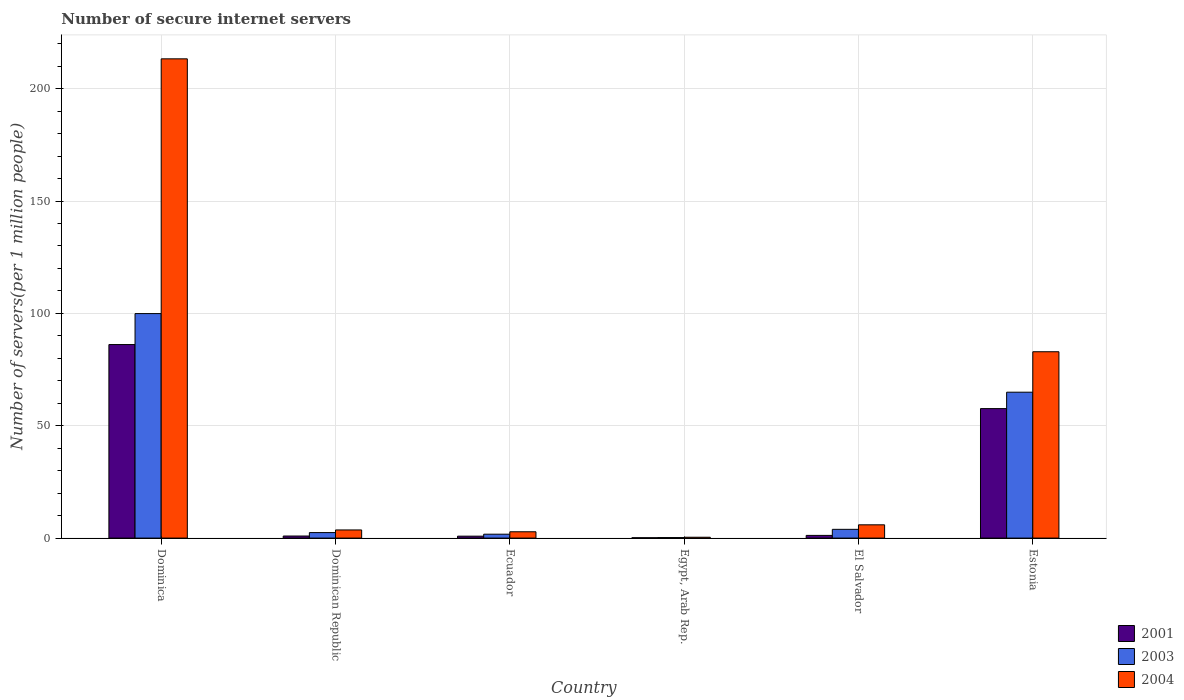How many different coloured bars are there?
Offer a terse response. 3. How many groups of bars are there?
Offer a terse response. 6. Are the number of bars per tick equal to the number of legend labels?
Provide a succinct answer. Yes. What is the label of the 5th group of bars from the left?
Make the answer very short. El Salvador. In how many cases, is the number of bars for a given country not equal to the number of legend labels?
Your response must be concise. 0. What is the number of secure internet servers in 2001 in Egypt, Arab Rep.?
Give a very brief answer. 0.16. Across all countries, what is the maximum number of secure internet servers in 2004?
Ensure brevity in your answer.  213.3. Across all countries, what is the minimum number of secure internet servers in 2004?
Offer a very short reply. 0.38. In which country was the number of secure internet servers in 2003 maximum?
Your answer should be very brief. Dominica. In which country was the number of secure internet servers in 2001 minimum?
Ensure brevity in your answer.  Egypt, Arab Rep. What is the total number of secure internet servers in 2001 in the graph?
Make the answer very short. 146.9. What is the difference between the number of secure internet servers in 2001 in Dominica and that in Egypt, Arab Rep.?
Make the answer very short. 85.97. What is the difference between the number of secure internet servers in 2004 in Estonia and the number of secure internet servers in 2003 in Dominica?
Offer a terse response. -16.98. What is the average number of secure internet servers in 2003 per country?
Your answer should be very brief. 28.86. What is the difference between the number of secure internet servers of/in 2003 and number of secure internet servers of/in 2001 in Estonia?
Give a very brief answer. 7.3. In how many countries, is the number of secure internet servers in 2004 greater than 130?
Make the answer very short. 1. What is the ratio of the number of secure internet servers in 2001 in El Salvador to that in Estonia?
Your answer should be very brief. 0.02. Is the number of secure internet servers in 2004 in El Salvador less than that in Estonia?
Provide a short and direct response. Yes. Is the difference between the number of secure internet servers in 2003 in Egypt, Arab Rep. and Estonia greater than the difference between the number of secure internet servers in 2001 in Egypt, Arab Rep. and Estonia?
Give a very brief answer. No. What is the difference between the highest and the second highest number of secure internet servers in 2003?
Offer a terse response. -34.99. What is the difference between the highest and the lowest number of secure internet servers in 2003?
Your response must be concise. 99.68. In how many countries, is the number of secure internet servers in 2003 greater than the average number of secure internet servers in 2003 taken over all countries?
Provide a succinct answer. 2. What does the 3rd bar from the right in Estonia represents?
Your answer should be compact. 2001. How many bars are there?
Provide a succinct answer. 18. Does the graph contain any zero values?
Ensure brevity in your answer.  No. Does the graph contain grids?
Make the answer very short. Yes. Where does the legend appear in the graph?
Ensure brevity in your answer.  Bottom right. How are the legend labels stacked?
Your answer should be compact. Vertical. What is the title of the graph?
Your answer should be very brief. Number of secure internet servers. Does "1970" appear as one of the legend labels in the graph?
Keep it short and to the point. No. What is the label or title of the X-axis?
Give a very brief answer. Country. What is the label or title of the Y-axis?
Give a very brief answer. Number of servers(per 1 million people). What is the Number of servers(per 1 million people) in 2001 in Dominica?
Your answer should be compact. 86.13. What is the Number of servers(per 1 million people) of 2003 in Dominica?
Provide a short and direct response. 99.92. What is the Number of servers(per 1 million people) of 2004 in Dominica?
Offer a very short reply. 213.3. What is the Number of servers(per 1 million people) in 2001 in Dominican Republic?
Offer a terse response. 0.92. What is the Number of servers(per 1 million people) in 2003 in Dominican Republic?
Ensure brevity in your answer.  2.45. What is the Number of servers(per 1 million people) of 2004 in Dominican Republic?
Provide a succinct answer. 3.63. What is the Number of servers(per 1 million people) of 2001 in Ecuador?
Ensure brevity in your answer.  0.86. What is the Number of servers(per 1 million people) in 2003 in Ecuador?
Your answer should be very brief. 1.73. What is the Number of servers(per 1 million people) in 2004 in Ecuador?
Your answer should be very brief. 2.81. What is the Number of servers(per 1 million people) of 2001 in Egypt, Arab Rep.?
Provide a succinct answer. 0.16. What is the Number of servers(per 1 million people) of 2003 in Egypt, Arab Rep.?
Your response must be concise. 0.24. What is the Number of servers(per 1 million people) in 2004 in Egypt, Arab Rep.?
Offer a very short reply. 0.38. What is the Number of servers(per 1 million people) in 2001 in El Salvador?
Your answer should be very brief. 1.2. What is the Number of servers(per 1 million people) in 2003 in El Salvador?
Provide a short and direct response. 3.9. What is the Number of servers(per 1 million people) in 2004 in El Salvador?
Your answer should be compact. 5.91. What is the Number of servers(per 1 million people) in 2001 in Estonia?
Your answer should be compact. 57.63. What is the Number of servers(per 1 million people) in 2003 in Estonia?
Ensure brevity in your answer.  64.93. What is the Number of servers(per 1 million people) in 2004 in Estonia?
Keep it short and to the point. 82.93. Across all countries, what is the maximum Number of servers(per 1 million people) in 2001?
Provide a short and direct response. 86.13. Across all countries, what is the maximum Number of servers(per 1 million people) of 2003?
Your answer should be compact. 99.92. Across all countries, what is the maximum Number of servers(per 1 million people) of 2004?
Keep it short and to the point. 213.3. Across all countries, what is the minimum Number of servers(per 1 million people) in 2001?
Your answer should be compact. 0.16. Across all countries, what is the minimum Number of servers(per 1 million people) of 2003?
Your response must be concise. 0.24. Across all countries, what is the minimum Number of servers(per 1 million people) of 2004?
Keep it short and to the point. 0.38. What is the total Number of servers(per 1 million people) in 2001 in the graph?
Offer a very short reply. 146.9. What is the total Number of servers(per 1 million people) of 2003 in the graph?
Your response must be concise. 173.16. What is the total Number of servers(per 1 million people) of 2004 in the graph?
Provide a short and direct response. 308.95. What is the difference between the Number of servers(per 1 million people) of 2001 in Dominica and that in Dominican Republic?
Your answer should be compact. 85.21. What is the difference between the Number of servers(per 1 million people) in 2003 in Dominica and that in Dominican Republic?
Offer a very short reply. 97.46. What is the difference between the Number of servers(per 1 million people) of 2004 in Dominica and that in Dominican Republic?
Make the answer very short. 209.67. What is the difference between the Number of servers(per 1 million people) in 2001 in Dominica and that in Ecuador?
Ensure brevity in your answer.  85.28. What is the difference between the Number of servers(per 1 million people) of 2003 in Dominica and that in Ecuador?
Ensure brevity in your answer.  98.19. What is the difference between the Number of servers(per 1 million people) in 2004 in Dominica and that in Ecuador?
Provide a short and direct response. 210.48. What is the difference between the Number of servers(per 1 million people) of 2001 in Dominica and that in Egypt, Arab Rep.?
Your response must be concise. 85.97. What is the difference between the Number of servers(per 1 million people) in 2003 in Dominica and that in Egypt, Arab Rep.?
Offer a very short reply. 99.68. What is the difference between the Number of servers(per 1 million people) of 2004 in Dominica and that in Egypt, Arab Rep.?
Give a very brief answer. 212.91. What is the difference between the Number of servers(per 1 million people) of 2001 in Dominica and that in El Salvador?
Keep it short and to the point. 84.94. What is the difference between the Number of servers(per 1 million people) of 2003 in Dominica and that in El Salvador?
Offer a very short reply. 96.02. What is the difference between the Number of servers(per 1 million people) in 2004 in Dominica and that in El Salvador?
Offer a terse response. 207.39. What is the difference between the Number of servers(per 1 million people) in 2001 in Dominica and that in Estonia?
Keep it short and to the point. 28.5. What is the difference between the Number of servers(per 1 million people) of 2003 in Dominica and that in Estonia?
Offer a terse response. 34.99. What is the difference between the Number of servers(per 1 million people) in 2004 in Dominica and that in Estonia?
Your answer should be very brief. 130.36. What is the difference between the Number of servers(per 1 million people) of 2001 in Dominican Republic and that in Ecuador?
Provide a short and direct response. 0.06. What is the difference between the Number of servers(per 1 million people) in 2003 in Dominican Republic and that in Ecuador?
Your answer should be compact. 0.72. What is the difference between the Number of servers(per 1 million people) in 2004 in Dominican Republic and that in Ecuador?
Your response must be concise. 0.81. What is the difference between the Number of servers(per 1 million people) of 2001 in Dominican Republic and that in Egypt, Arab Rep.?
Offer a very short reply. 0.76. What is the difference between the Number of servers(per 1 million people) in 2003 in Dominican Republic and that in Egypt, Arab Rep.?
Your response must be concise. 2.22. What is the difference between the Number of servers(per 1 million people) of 2004 in Dominican Republic and that in Egypt, Arab Rep.?
Provide a short and direct response. 3.24. What is the difference between the Number of servers(per 1 million people) of 2001 in Dominican Republic and that in El Salvador?
Provide a short and direct response. -0.28. What is the difference between the Number of servers(per 1 million people) in 2003 in Dominican Republic and that in El Salvador?
Make the answer very short. -1.44. What is the difference between the Number of servers(per 1 million people) of 2004 in Dominican Republic and that in El Salvador?
Give a very brief answer. -2.28. What is the difference between the Number of servers(per 1 million people) in 2001 in Dominican Republic and that in Estonia?
Ensure brevity in your answer.  -56.71. What is the difference between the Number of servers(per 1 million people) of 2003 in Dominican Republic and that in Estonia?
Keep it short and to the point. -62.48. What is the difference between the Number of servers(per 1 million people) in 2004 in Dominican Republic and that in Estonia?
Provide a succinct answer. -79.31. What is the difference between the Number of servers(per 1 million people) in 2001 in Ecuador and that in Egypt, Arab Rep.?
Make the answer very short. 0.7. What is the difference between the Number of servers(per 1 million people) in 2003 in Ecuador and that in Egypt, Arab Rep.?
Provide a short and direct response. 1.5. What is the difference between the Number of servers(per 1 million people) of 2004 in Ecuador and that in Egypt, Arab Rep.?
Offer a terse response. 2.43. What is the difference between the Number of servers(per 1 million people) of 2001 in Ecuador and that in El Salvador?
Provide a short and direct response. -0.34. What is the difference between the Number of servers(per 1 million people) in 2003 in Ecuador and that in El Salvador?
Provide a succinct answer. -2.17. What is the difference between the Number of servers(per 1 million people) in 2004 in Ecuador and that in El Salvador?
Your answer should be very brief. -3.09. What is the difference between the Number of servers(per 1 million people) in 2001 in Ecuador and that in Estonia?
Offer a terse response. -56.78. What is the difference between the Number of servers(per 1 million people) in 2003 in Ecuador and that in Estonia?
Your answer should be compact. -63.2. What is the difference between the Number of servers(per 1 million people) of 2004 in Ecuador and that in Estonia?
Your response must be concise. -80.12. What is the difference between the Number of servers(per 1 million people) in 2001 in Egypt, Arab Rep. and that in El Salvador?
Make the answer very short. -1.04. What is the difference between the Number of servers(per 1 million people) in 2003 in Egypt, Arab Rep. and that in El Salvador?
Your answer should be very brief. -3.66. What is the difference between the Number of servers(per 1 million people) of 2004 in Egypt, Arab Rep. and that in El Salvador?
Keep it short and to the point. -5.53. What is the difference between the Number of servers(per 1 million people) in 2001 in Egypt, Arab Rep. and that in Estonia?
Offer a terse response. -57.47. What is the difference between the Number of servers(per 1 million people) in 2003 in Egypt, Arab Rep. and that in Estonia?
Make the answer very short. -64.69. What is the difference between the Number of servers(per 1 million people) of 2004 in Egypt, Arab Rep. and that in Estonia?
Your response must be concise. -82.55. What is the difference between the Number of servers(per 1 million people) of 2001 in El Salvador and that in Estonia?
Your answer should be very brief. -56.43. What is the difference between the Number of servers(per 1 million people) in 2003 in El Salvador and that in Estonia?
Keep it short and to the point. -61.03. What is the difference between the Number of servers(per 1 million people) in 2004 in El Salvador and that in Estonia?
Offer a very short reply. -77.03. What is the difference between the Number of servers(per 1 million people) in 2001 in Dominica and the Number of servers(per 1 million people) in 2003 in Dominican Republic?
Your answer should be compact. 83.68. What is the difference between the Number of servers(per 1 million people) in 2001 in Dominica and the Number of servers(per 1 million people) in 2004 in Dominican Republic?
Your response must be concise. 82.51. What is the difference between the Number of servers(per 1 million people) in 2003 in Dominica and the Number of servers(per 1 million people) in 2004 in Dominican Republic?
Your response must be concise. 96.29. What is the difference between the Number of servers(per 1 million people) of 2001 in Dominica and the Number of servers(per 1 million people) of 2003 in Ecuador?
Give a very brief answer. 84.4. What is the difference between the Number of servers(per 1 million people) in 2001 in Dominica and the Number of servers(per 1 million people) in 2004 in Ecuador?
Your answer should be very brief. 83.32. What is the difference between the Number of servers(per 1 million people) in 2003 in Dominica and the Number of servers(per 1 million people) in 2004 in Ecuador?
Your response must be concise. 97.1. What is the difference between the Number of servers(per 1 million people) in 2001 in Dominica and the Number of servers(per 1 million people) in 2003 in Egypt, Arab Rep.?
Provide a succinct answer. 85.9. What is the difference between the Number of servers(per 1 million people) in 2001 in Dominica and the Number of servers(per 1 million people) in 2004 in Egypt, Arab Rep.?
Ensure brevity in your answer.  85.75. What is the difference between the Number of servers(per 1 million people) in 2003 in Dominica and the Number of servers(per 1 million people) in 2004 in Egypt, Arab Rep.?
Offer a terse response. 99.54. What is the difference between the Number of servers(per 1 million people) in 2001 in Dominica and the Number of servers(per 1 million people) in 2003 in El Salvador?
Ensure brevity in your answer.  82.23. What is the difference between the Number of servers(per 1 million people) in 2001 in Dominica and the Number of servers(per 1 million people) in 2004 in El Salvador?
Give a very brief answer. 80.23. What is the difference between the Number of servers(per 1 million people) in 2003 in Dominica and the Number of servers(per 1 million people) in 2004 in El Salvador?
Provide a short and direct response. 94.01. What is the difference between the Number of servers(per 1 million people) of 2001 in Dominica and the Number of servers(per 1 million people) of 2003 in Estonia?
Provide a short and direct response. 21.2. What is the difference between the Number of servers(per 1 million people) in 2001 in Dominica and the Number of servers(per 1 million people) in 2004 in Estonia?
Offer a terse response. 3.2. What is the difference between the Number of servers(per 1 million people) of 2003 in Dominica and the Number of servers(per 1 million people) of 2004 in Estonia?
Give a very brief answer. 16.98. What is the difference between the Number of servers(per 1 million people) of 2001 in Dominican Republic and the Number of servers(per 1 million people) of 2003 in Ecuador?
Offer a very short reply. -0.81. What is the difference between the Number of servers(per 1 million people) in 2001 in Dominican Republic and the Number of servers(per 1 million people) in 2004 in Ecuador?
Make the answer very short. -1.89. What is the difference between the Number of servers(per 1 million people) in 2003 in Dominican Republic and the Number of servers(per 1 million people) in 2004 in Ecuador?
Your response must be concise. -0.36. What is the difference between the Number of servers(per 1 million people) in 2001 in Dominican Republic and the Number of servers(per 1 million people) in 2003 in Egypt, Arab Rep.?
Offer a terse response. 0.68. What is the difference between the Number of servers(per 1 million people) in 2001 in Dominican Republic and the Number of servers(per 1 million people) in 2004 in Egypt, Arab Rep.?
Ensure brevity in your answer.  0.54. What is the difference between the Number of servers(per 1 million people) of 2003 in Dominican Republic and the Number of servers(per 1 million people) of 2004 in Egypt, Arab Rep.?
Your answer should be compact. 2.07. What is the difference between the Number of servers(per 1 million people) of 2001 in Dominican Republic and the Number of servers(per 1 million people) of 2003 in El Salvador?
Your answer should be very brief. -2.98. What is the difference between the Number of servers(per 1 million people) in 2001 in Dominican Republic and the Number of servers(per 1 million people) in 2004 in El Salvador?
Your response must be concise. -4.99. What is the difference between the Number of servers(per 1 million people) in 2003 in Dominican Republic and the Number of servers(per 1 million people) in 2004 in El Salvador?
Offer a terse response. -3.45. What is the difference between the Number of servers(per 1 million people) of 2001 in Dominican Republic and the Number of servers(per 1 million people) of 2003 in Estonia?
Keep it short and to the point. -64.01. What is the difference between the Number of servers(per 1 million people) of 2001 in Dominican Republic and the Number of servers(per 1 million people) of 2004 in Estonia?
Your answer should be compact. -82.01. What is the difference between the Number of servers(per 1 million people) in 2003 in Dominican Republic and the Number of servers(per 1 million people) in 2004 in Estonia?
Provide a short and direct response. -80.48. What is the difference between the Number of servers(per 1 million people) in 2001 in Ecuador and the Number of servers(per 1 million people) in 2003 in Egypt, Arab Rep.?
Provide a short and direct response. 0.62. What is the difference between the Number of servers(per 1 million people) of 2001 in Ecuador and the Number of servers(per 1 million people) of 2004 in Egypt, Arab Rep.?
Provide a short and direct response. 0.48. What is the difference between the Number of servers(per 1 million people) in 2003 in Ecuador and the Number of servers(per 1 million people) in 2004 in Egypt, Arab Rep.?
Your answer should be compact. 1.35. What is the difference between the Number of servers(per 1 million people) in 2001 in Ecuador and the Number of servers(per 1 million people) in 2003 in El Salvador?
Ensure brevity in your answer.  -3.04. What is the difference between the Number of servers(per 1 million people) of 2001 in Ecuador and the Number of servers(per 1 million people) of 2004 in El Salvador?
Give a very brief answer. -5.05. What is the difference between the Number of servers(per 1 million people) in 2003 in Ecuador and the Number of servers(per 1 million people) in 2004 in El Salvador?
Provide a short and direct response. -4.18. What is the difference between the Number of servers(per 1 million people) in 2001 in Ecuador and the Number of servers(per 1 million people) in 2003 in Estonia?
Provide a short and direct response. -64.07. What is the difference between the Number of servers(per 1 million people) of 2001 in Ecuador and the Number of servers(per 1 million people) of 2004 in Estonia?
Your response must be concise. -82.08. What is the difference between the Number of servers(per 1 million people) of 2003 in Ecuador and the Number of servers(per 1 million people) of 2004 in Estonia?
Provide a succinct answer. -81.2. What is the difference between the Number of servers(per 1 million people) of 2001 in Egypt, Arab Rep. and the Number of servers(per 1 million people) of 2003 in El Salvador?
Ensure brevity in your answer.  -3.74. What is the difference between the Number of servers(per 1 million people) of 2001 in Egypt, Arab Rep. and the Number of servers(per 1 million people) of 2004 in El Salvador?
Offer a very short reply. -5.75. What is the difference between the Number of servers(per 1 million people) in 2003 in Egypt, Arab Rep. and the Number of servers(per 1 million people) in 2004 in El Salvador?
Provide a short and direct response. -5.67. What is the difference between the Number of servers(per 1 million people) of 2001 in Egypt, Arab Rep. and the Number of servers(per 1 million people) of 2003 in Estonia?
Your answer should be very brief. -64.77. What is the difference between the Number of servers(per 1 million people) of 2001 in Egypt, Arab Rep. and the Number of servers(per 1 million people) of 2004 in Estonia?
Your answer should be very brief. -82.77. What is the difference between the Number of servers(per 1 million people) of 2003 in Egypt, Arab Rep. and the Number of servers(per 1 million people) of 2004 in Estonia?
Your answer should be very brief. -82.7. What is the difference between the Number of servers(per 1 million people) of 2001 in El Salvador and the Number of servers(per 1 million people) of 2003 in Estonia?
Ensure brevity in your answer.  -63.73. What is the difference between the Number of servers(per 1 million people) in 2001 in El Salvador and the Number of servers(per 1 million people) in 2004 in Estonia?
Your answer should be very brief. -81.74. What is the difference between the Number of servers(per 1 million people) of 2003 in El Salvador and the Number of servers(per 1 million people) of 2004 in Estonia?
Keep it short and to the point. -79.03. What is the average Number of servers(per 1 million people) in 2001 per country?
Offer a very short reply. 24.48. What is the average Number of servers(per 1 million people) in 2003 per country?
Your answer should be compact. 28.86. What is the average Number of servers(per 1 million people) of 2004 per country?
Provide a short and direct response. 51.49. What is the difference between the Number of servers(per 1 million people) in 2001 and Number of servers(per 1 million people) in 2003 in Dominica?
Offer a terse response. -13.78. What is the difference between the Number of servers(per 1 million people) in 2001 and Number of servers(per 1 million people) in 2004 in Dominica?
Keep it short and to the point. -127.16. What is the difference between the Number of servers(per 1 million people) in 2003 and Number of servers(per 1 million people) in 2004 in Dominica?
Offer a terse response. -113.38. What is the difference between the Number of servers(per 1 million people) in 2001 and Number of servers(per 1 million people) in 2003 in Dominican Republic?
Offer a terse response. -1.53. What is the difference between the Number of servers(per 1 million people) of 2001 and Number of servers(per 1 million people) of 2004 in Dominican Republic?
Provide a succinct answer. -2.71. What is the difference between the Number of servers(per 1 million people) in 2003 and Number of servers(per 1 million people) in 2004 in Dominican Republic?
Your response must be concise. -1.17. What is the difference between the Number of servers(per 1 million people) of 2001 and Number of servers(per 1 million people) of 2003 in Ecuador?
Make the answer very short. -0.87. What is the difference between the Number of servers(per 1 million people) in 2001 and Number of servers(per 1 million people) in 2004 in Ecuador?
Your answer should be compact. -1.96. What is the difference between the Number of servers(per 1 million people) of 2003 and Number of servers(per 1 million people) of 2004 in Ecuador?
Your answer should be compact. -1.08. What is the difference between the Number of servers(per 1 million people) in 2001 and Number of servers(per 1 million people) in 2003 in Egypt, Arab Rep.?
Provide a short and direct response. -0.08. What is the difference between the Number of servers(per 1 million people) of 2001 and Number of servers(per 1 million people) of 2004 in Egypt, Arab Rep.?
Give a very brief answer. -0.22. What is the difference between the Number of servers(per 1 million people) of 2003 and Number of servers(per 1 million people) of 2004 in Egypt, Arab Rep.?
Provide a succinct answer. -0.15. What is the difference between the Number of servers(per 1 million people) of 2001 and Number of servers(per 1 million people) of 2004 in El Salvador?
Give a very brief answer. -4.71. What is the difference between the Number of servers(per 1 million people) in 2003 and Number of servers(per 1 million people) in 2004 in El Salvador?
Give a very brief answer. -2.01. What is the difference between the Number of servers(per 1 million people) in 2001 and Number of servers(per 1 million people) in 2003 in Estonia?
Make the answer very short. -7.3. What is the difference between the Number of servers(per 1 million people) of 2001 and Number of servers(per 1 million people) of 2004 in Estonia?
Ensure brevity in your answer.  -25.3. What is the difference between the Number of servers(per 1 million people) in 2003 and Number of servers(per 1 million people) in 2004 in Estonia?
Give a very brief answer. -18. What is the ratio of the Number of servers(per 1 million people) in 2001 in Dominica to that in Dominican Republic?
Provide a short and direct response. 93.64. What is the ratio of the Number of servers(per 1 million people) of 2003 in Dominica to that in Dominican Republic?
Your answer should be compact. 40.73. What is the ratio of the Number of servers(per 1 million people) of 2004 in Dominica to that in Dominican Republic?
Make the answer very short. 58.84. What is the ratio of the Number of servers(per 1 million people) of 2001 in Dominica to that in Ecuador?
Keep it short and to the point. 100.64. What is the ratio of the Number of servers(per 1 million people) of 2003 in Dominica to that in Ecuador?
Your answer should be very brief. 57.73. What is the ratio of the Number of servers(per 1 million people) in 2004 in Dominica to that in Ecuador?
Ensure brevity in your answer.  75.83. What is the ratio of the Number of servers(per 1 million people) in 2001 in Dominica to that in Egypt, Arab Rep.?
Your answer should be compact. 544.98. What is the ratio of the Number of servers(per 1 million people) in 2003 in Dominica to that in Egypt, Arab Rep.?
Make the answer very short. 424.63. What is the ratio of the Number of servers(per 1 million people) in 2004 in Dominica to that in Egypt, Arab Rep.?
Your response must be concise. 560.63. What is the ratio of the Number of servers(per 1 million people) of 2001 in Dominica to that in El Salvador?
Provide a short and direct response. 71.92. What is the ratio of the Number of servers(per 1 million people) of 2003 in Dominica to that in El Salvador?
Offer a terse response. 25.64. What is the ratio of the Number of servers(per 1 million people) in 2004 in Dominica to that in El Salvador?
Provide a short and direct response. 36.11. What is the ratio of the Number of servers(per 1 million people) in 2001 in Dominica to that in Estonia?
Make the answer very short. 1.49. What is the ratio of the Number of servers(per 1 million people) in 2003 in Dominica to that in Estonia?
Provide a short and direct response. 1.54. What is the ratio of the Number of servers(per 1 million people) in 2004 in Dominica to that in Estonia?
Keep it short and to the point. 2.57. What is the ratio of the Number of servers(per 1 million people) of 2001 in Dominican Republic to that in Ecuador?
Your answer should be compact. 1.07. What is the ratio of the Number of servers(per 1 million people) in 2003 in Dominican Republic to that in Ecuador?
Ensure brevity in your answer.  1.42. What is the ratio of the Number of servers(per 1 million people) in 2004 in Dominican Republic to that in Ecuador?
Give a very brief answer. 1.29. What is the ratio of the Number of servers(per 1 million people) of 2001 in Dominican Republic to that in Egypt, Arab Rep.?
Your response must be concise. 5.82. What is the ratio of the Number of servers(per 1 million people) of 2003 in Dominican Republic to that in Egypt, Arab Rep.?
Ensure brevity in your answer.  10.43. What is the ratio of the Number of servers(per 1 million people) of 2004 in Dominican Republic to that in Egypt, Arab Rep.?
Ensure brevity in your answer.  9.53. What is the ratio of the Number of servers(per 1 million people) in 2001 in Dominican Republic to that in El Salvador?
Your answer should be very brief. 0.77. What is the ratio of the Number of servers(per 1 million people) in 2003 in Dominican Republic to that in El Salvador?
Provide a short and direct response. 0.63. What is the ratio of the Number of servers(per 1 million people) of 2004 in Dominican Republic to that in El Salvador?
Ensure brevity in your answer.  0.61. What is the ratio of the Number of servers(per 1 million people) in 2001 in Dominican Republic to that in Estonia?
Give a very brief answer. 0.02. What is the ratio of the Number of servers(per 1 million people) of 2003 in Dominican Republic to that in Estonia?
Offer a terse response. 0.04. What is the ratio of the Number of servers(per 1 million people) of 2004 in Dominican Republic to that in Estonia?
Offer a very short reply. 0.04. What is the ratio of the Number of servers(per 1 million people) in 2001 in Ecuador to that in Egypt, Arab Rep.?
Give a very brief answer. 5.42. What is the ratio of the Number of servers(per 1 million people) in 2003 in Ecuador to that in Egypt, Arab Rep.?
Offer a very short reply. 7.36. What is the ratio of the Number of servers(per 1 million people) of 2004 in Ecuador to that in Egypt, Arab Rep.?
Offer a very short reply. 7.39. What is the ratio of the Number of servers(per 1 million people) in 2001 in Ecuador to that in El Salvador?
Your answer should be very brief. 0.71. What is the ratio of the Number of servers(per 1 million people) of 2003 in Ecuador to that in El Salvador?
Your response must be concise. 0.44. What is the ratio of the Number of servers(per 1 million people) of 2004 in Ecuador to that in El Salvador?
Provide a succinct answer. 0.48. What is the ratio of the Number of servers(per 1 million people) of 2001 in Ecuador to that in Estonia?
Provide a short and direct response. 0.01. What is the ratio of the Number of servers(per 1 million people) of 2003 in Ecuador to that in Estonia?
Your answer should be very brief. 0.03. What is the ratio of the Number of servers(per 1 million people) in 2004 in Ecuador to that in Estonia?
Keep it short and to the point. 0.03. What is the ratio of the Number of servers(per 1 million people) in 2001 in Egypt, Arab Rep. to that in El Salvador?
Offer a terse response. 0.13. What is the ratio of the Number of servers(per 1 million people) in 2003 in Egypt, Arab Rep. to that in El Salvador?
Provide a succinct answer. 0.06. What is the ratio of the Number of servers(per 1 million people) of 2004 in Egypt, Arab Rep. to that in El Salvador?
Offer a very short reply. 0.06. What is the ratio of the Number of servers(per 1 million people) of 2001 in Egypt, Arab Rep. to that in Estonia?
Offer a very short reply. 0. What is the ratio of the Number of servers(per 1 million people) in 2003 in Egypt, Arab Rep. to that in Estonia?
Make the answer very short. 0. What is the ratio of the Number of servers(per 1 million people) of 2004 in Egypt, Arab Rep. to that in Estonia?
Offer a very short reply. 0. What is the ratio of the Number of servers(per 1 million people) in 2001 in El Salvador to that in Estonia?
Offer a very short reply. 0.02. What is the ratio of the Number of servers(per 1 million people) in 2004 in El Salvador to that in Estonia?
Give a very brief answer. 0.07. What is the difference between the highest and the second highest Number of servers(per 1 million people) in 2001?
Offer a terse response. 28.5. What is the difference between the highest and the second highest Number of servers(per 1 million people) in 2003?
Make the answer very short. 34.99. What is the difference between the highest and the second highest Number of servers(per 1 million people) of 2004?
Keep it short and to the point. 130.36. What is the difference between the highest and the lowest Number of servers(per 1 million people) of 2001?
Give a very brief answer. 85.97. What is the difference between the highest and the lowest Number of servers(per 1 million people) of 2003?
Your response must be concise. 99.68. What is the difference between the highest and the lowest Number of servers(per 1 million people) of 2004?
Provide a succinct answer. 212.91. 